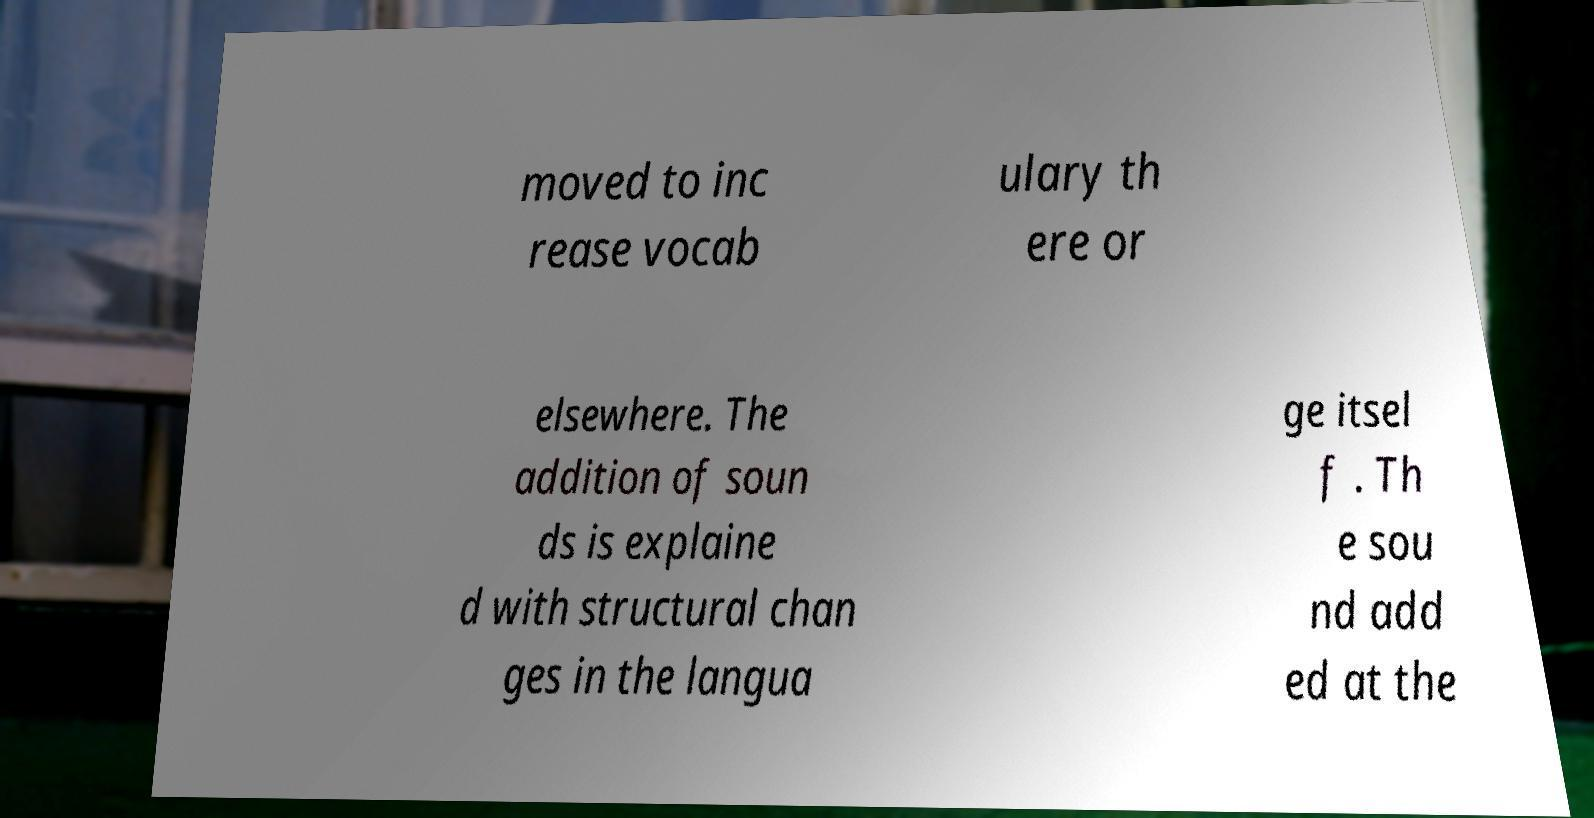What messages or text are displayed in this image? I need them in a readable, typed format. moved to inc rease vocab ulary th ere or elsewhere. The addition of soun ds is explaine d with structural chan ges in the langua ge itsel f . Th e sou nd add ed at the 